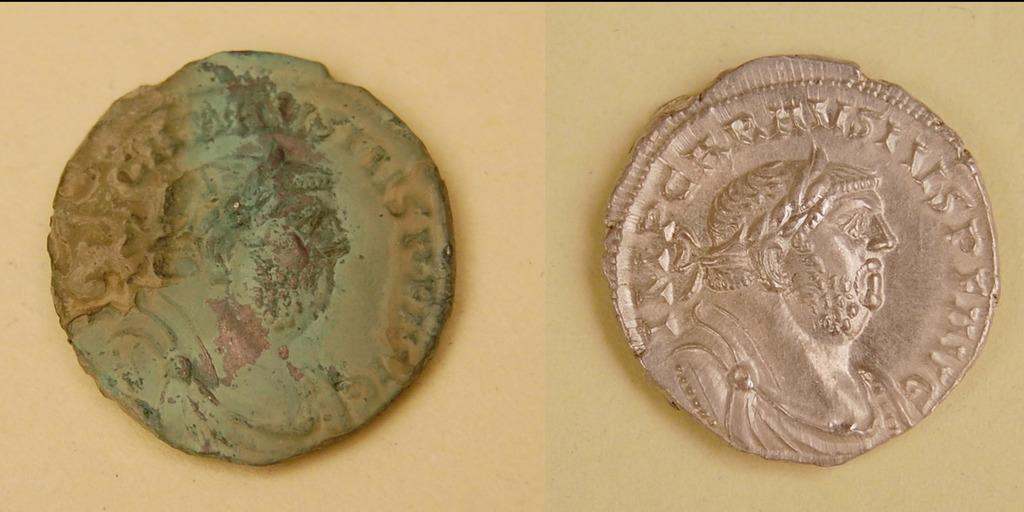What objects can be seen in the image? There are coins in the image. What can be observed about the background of the image? The background of the image is plain. How many clovers are present in the image? There are no clovers present in the image; it only features coins. What type of marble is visible in the image? There is no marble present in the image. 